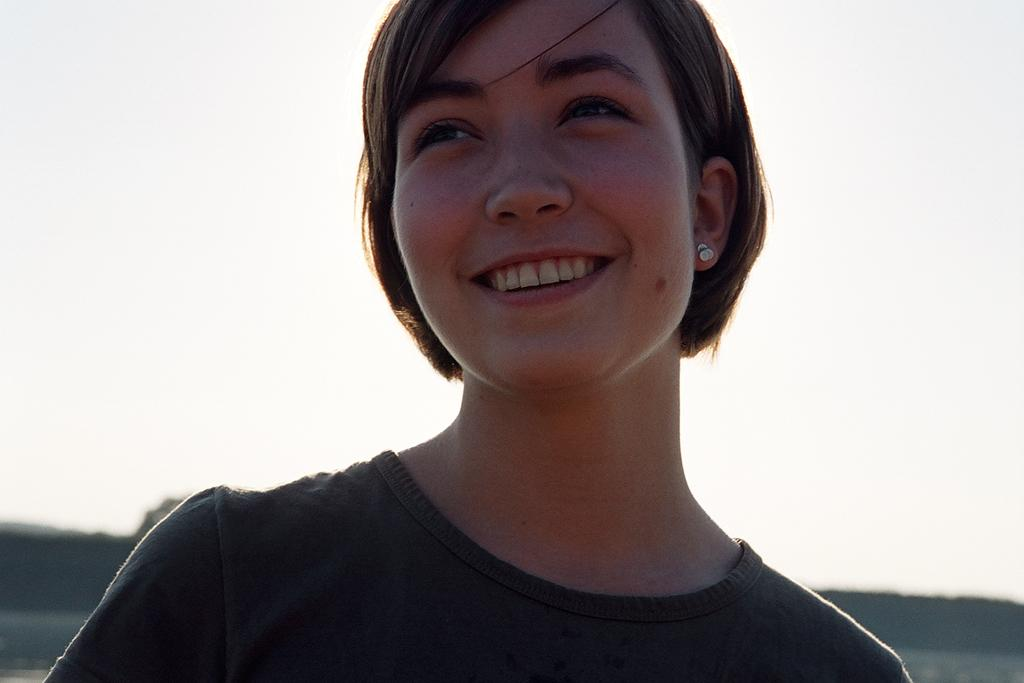What is the main subject of the image? There is a person in the image. Can you describe the person's appearance? The person is wearing clothes. What can be observed about the background of the image? The background of the image is blurred. What type of meat is the person holding in the image? There is no meat present in the image; the person is wearing clothes and standing in a blurred background. 